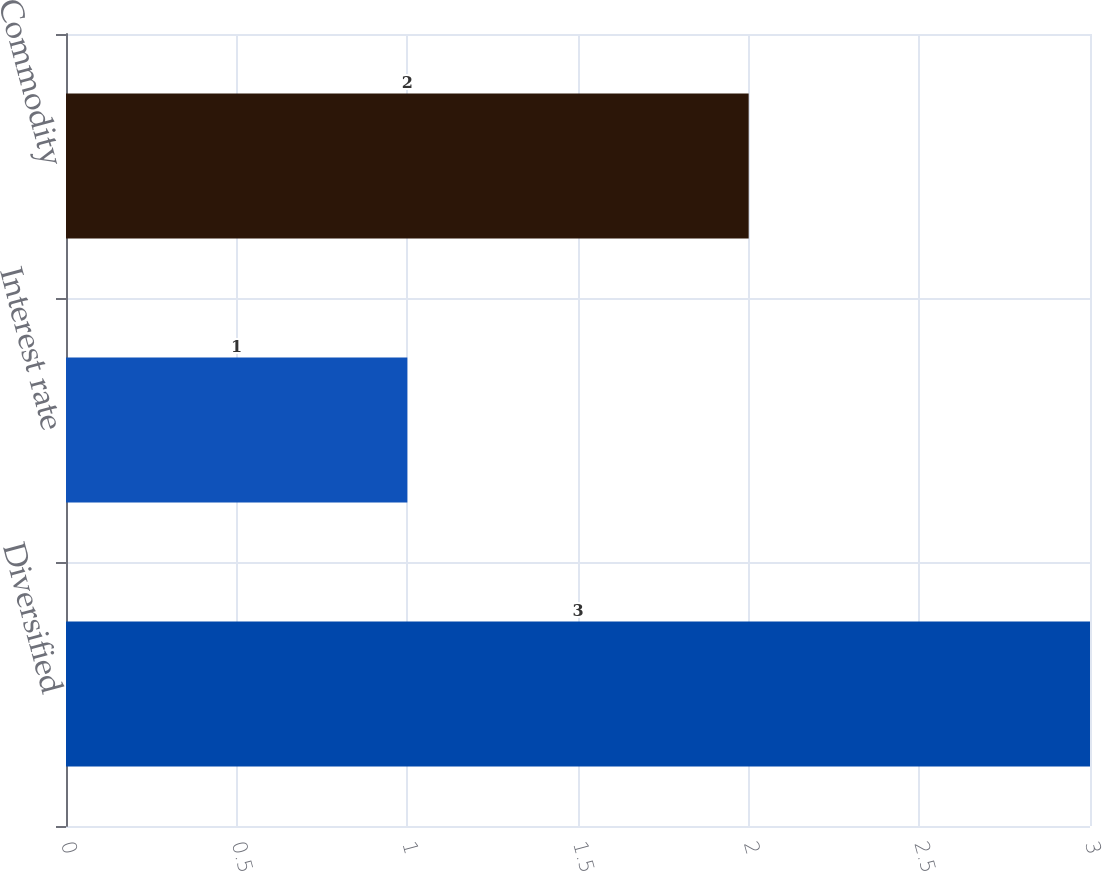<chart> <loc_0><loc_0><loc_500><loc_500><bar_chart><fcel>Diversified<fcel>Interest rate<fcel>Commodity<nl><fcel>3<fcel>1<fcel>2<nl></chart> 